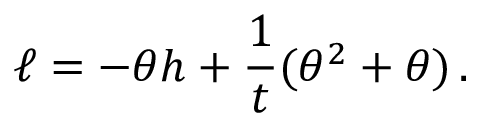Convert formula to latex. <formula><loc_0><loc_0><loc_500><loc_500>\ell = - \theta h + \frac { 1 } { t } ( \theta ^ { 2 } + \theta ) \, .</formula> 